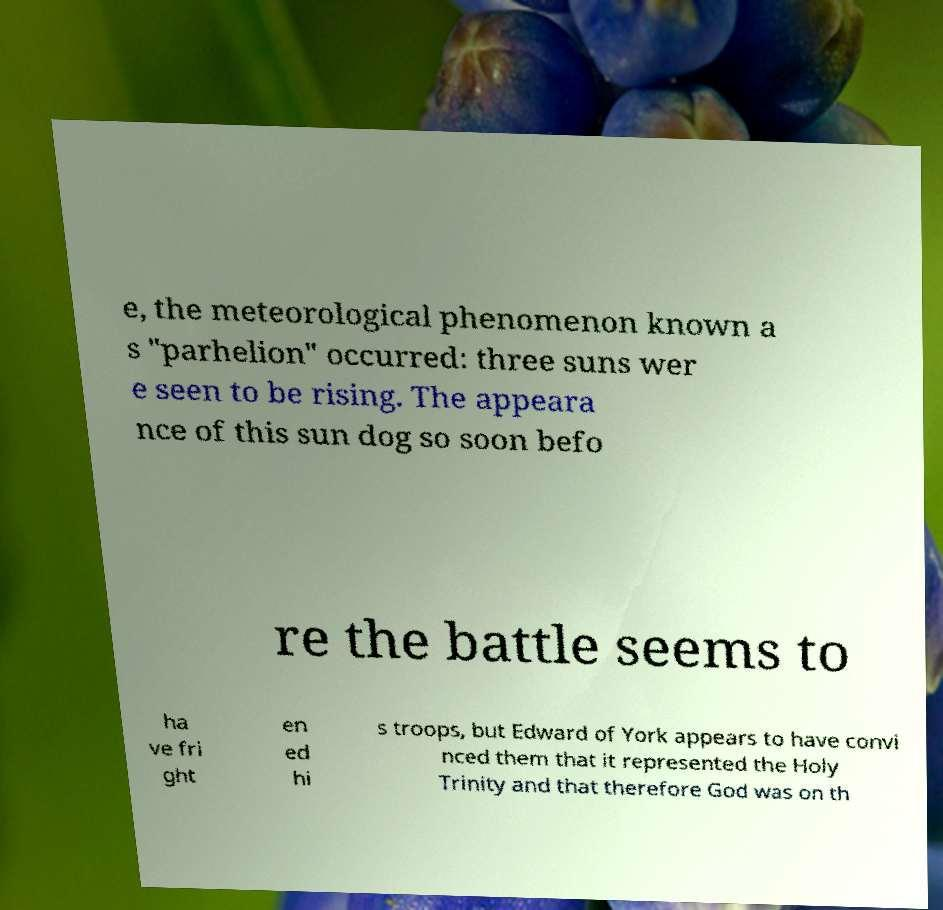I need the written content from this picture converted into text. Can you do that? e, the meteorological phenomenon known a s "parhelion" occurred: three suns wer e seen to be rising. The appeara nce of this sun dog so soon befo re the battle seems to ha ve fri ght en ed hi s troops, but Edward of York appears to have convi nced them that it represented the Holy Trinity and that therefore God was on th 